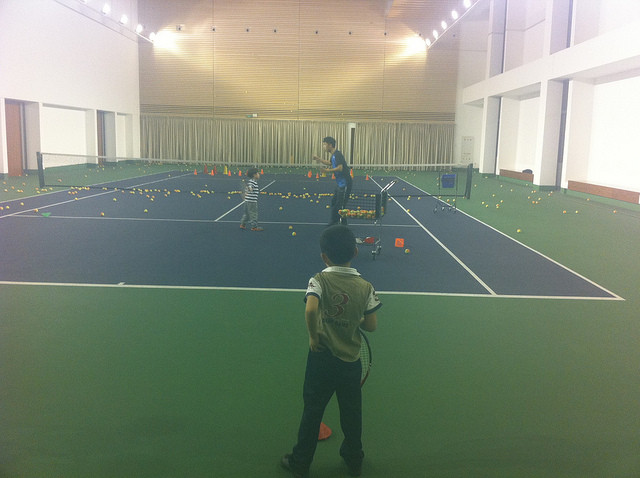Please transcribe the text in this image. 3 